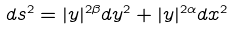<formula> <loc_0><loc_0><loc_500><loc_500>d s ^ { 2 } = | { y } | ^ { 2 \beta } d { y } ^ { 2 } + | { y } | ^ { 2 \alpha } d { x } ^ { 2 }</formula> 